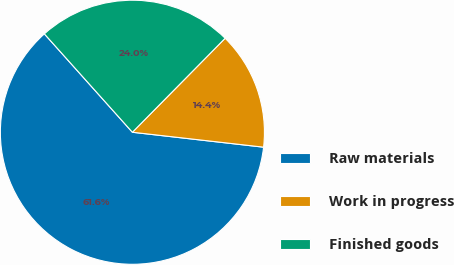Convert chart. <chart><loc_0><loc_0><loc_500><loc_500><pie_chart><fcel>Raw materials<fcel>Work in progress<fcel>Finished goods<nl><fcel>61.58%<fcel>14.41%<fcel>24.01%<nl></chart> 